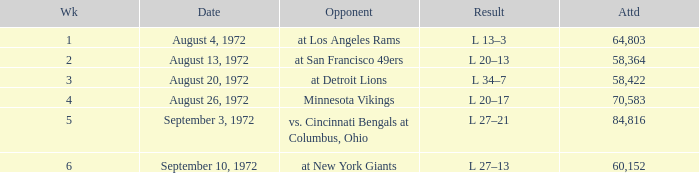What is the lowest attendance on September 3, 1972? 84816.0. 